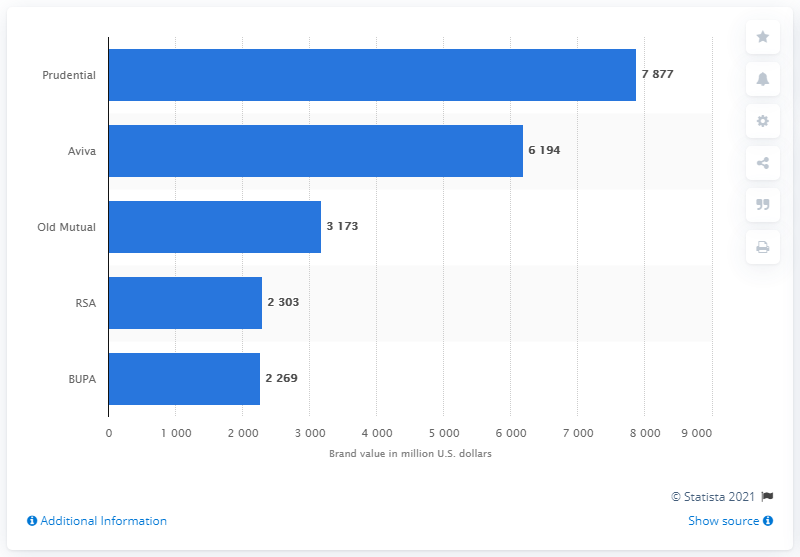What was Prudential's brand value in US dollars?
 7877 